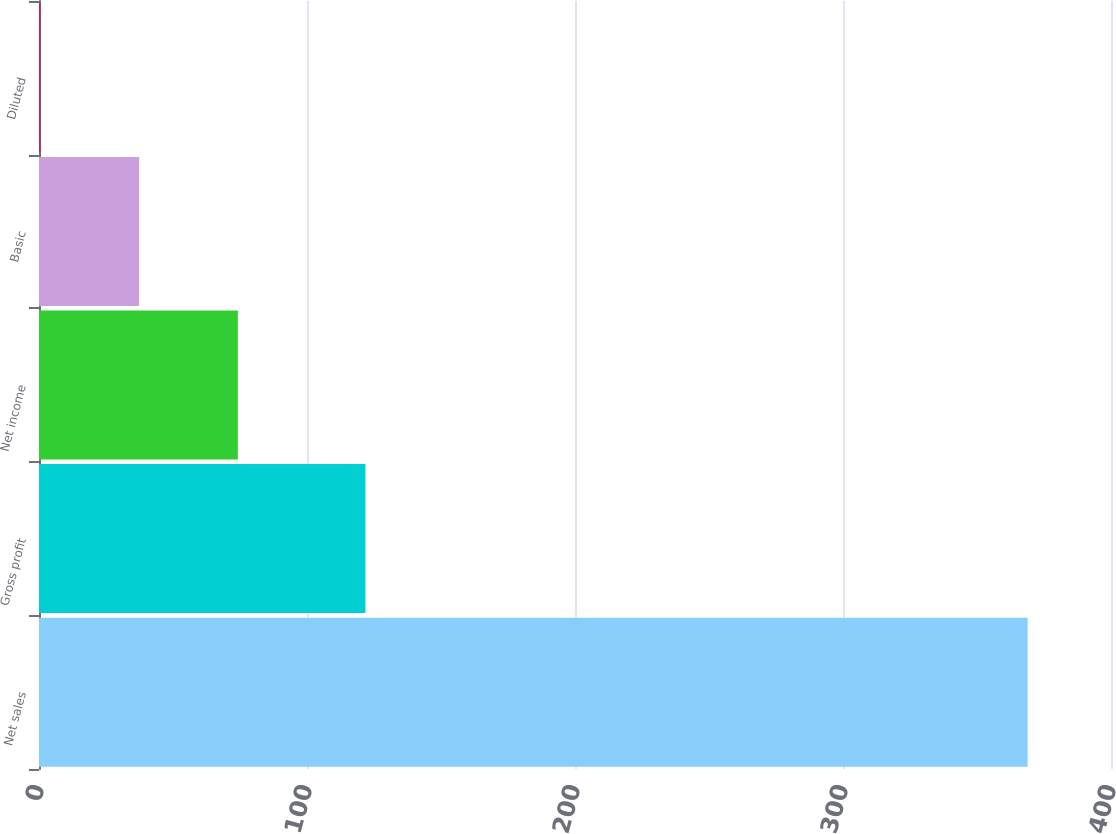Convert chart to OTSL. <chart><loc_0><loc_0><loc_500><loc_500><bar_chart><fcel>Net sales<fcel>Gross profit<fcel>Net income<fcel>Basic<fcel>Diluted<nl><fcel>368.9<fcel>121.8<fcel>74.2<fcel>37.36<fcel>0.52<nl></chart> 